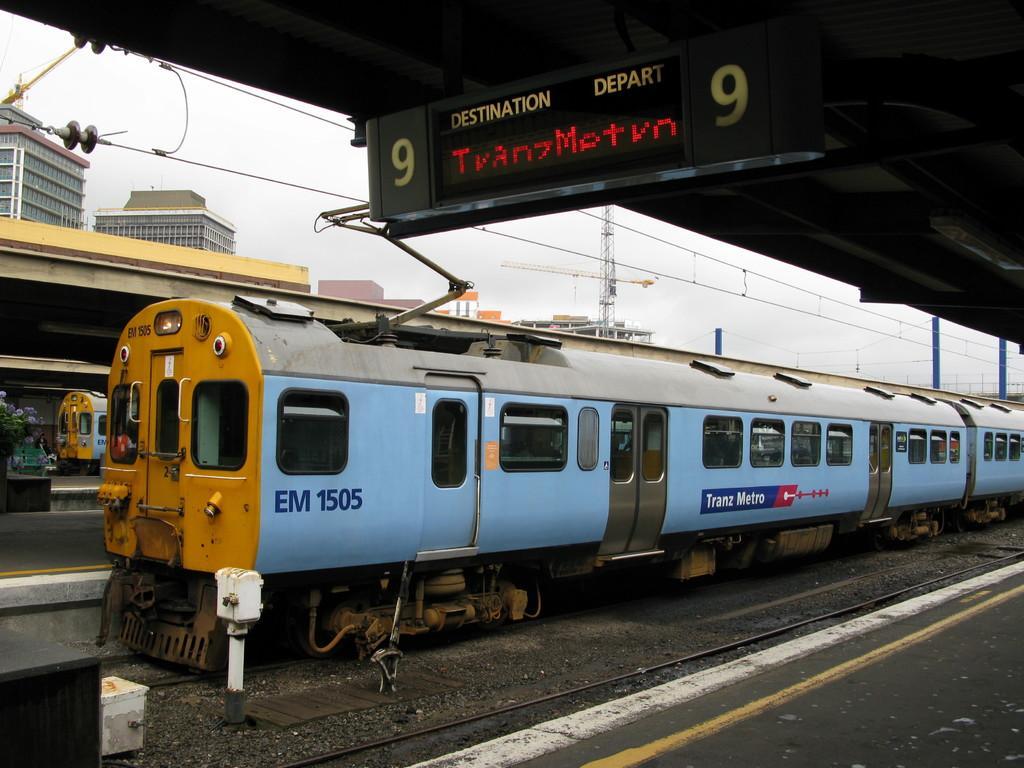In one or two sentences, can you explain what this image depicts? In the middle of the picture, we see a train in blue and yellow color is on the tracks. At the bottom, we see the railway tracks and the platform. Behind the train, we see the platform and we see the another train. There are buildings, towers and the wires in the background. At the top, we see the display screen which is displaying the text and we even see the roof of the platform. 